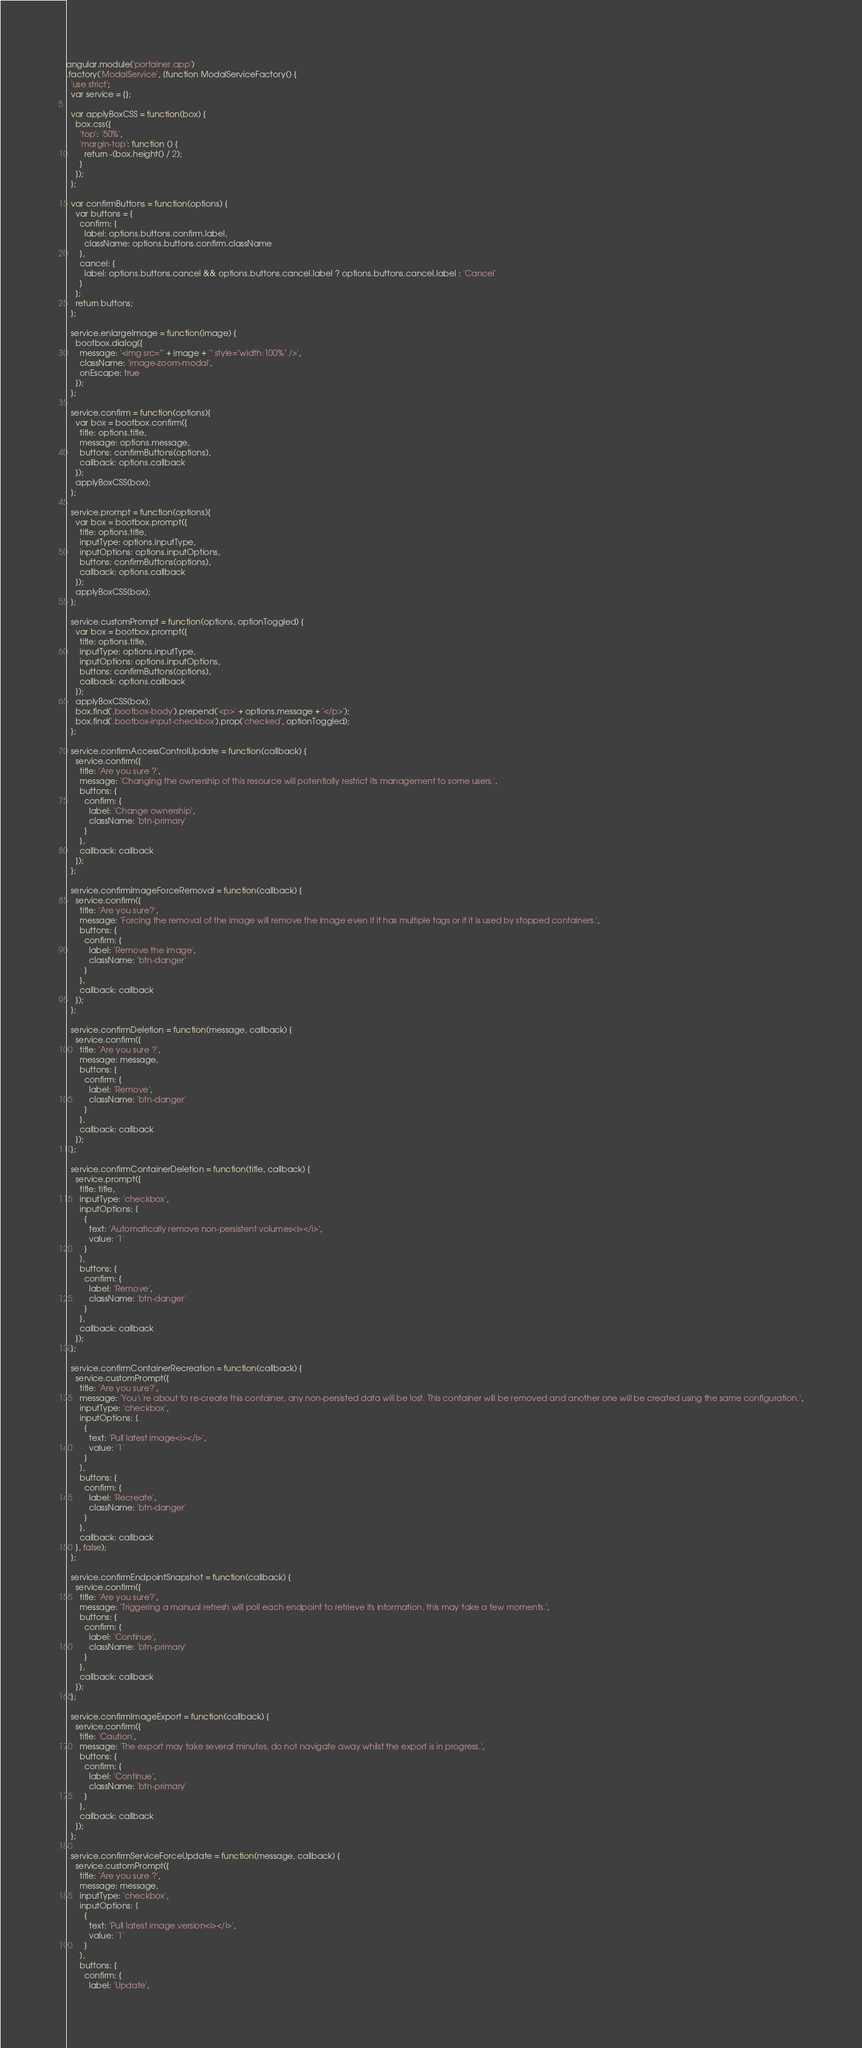Convert code to text. <code><loc_0><loc_0><loc_500><loc_500><_JavaScript_>angular.module('portainer.app')
.factory('ModalService', [function ModalServiceFactory() {
  'use strict';
  var service = {};

  var applyBoxCSS = function(box) {
    box.css({
      'top': '50%',
      'margin-top': function () {
        return -(box.height() / 2);
      }
    });
  };

  var confirmButtons = function(options) {
    var buttons = {
      confirm: {
        label: options.buttons.confirm.label,
        className: options.buttons.confirm.className
      },
      cancel: {
        label: options.buttons.cancel && options.buttons.cancel.label ? options.buttons.cancel.label : 'Cancel'
      }
    };
    return buttons;
  };

  service.enlargeImage = function(image) {
    bootbox.dialog({
      message: '<img src="' + image + '" style="width:100%" />',
      className: 'image-zoom-modal',
      onEscape: true
    });
  };

  service.confirm = function(options){
    var box = bootbox.confirm({
      title: options.title,
      message: options.message,
      buttons: confirmButtons(options),
      callback: options.callback
    });
    applyBoxCSS(box);
  };

  service.prompt = function(options){
    var box = bootbox.prompt({
      title: options.title,
      inputType: options.inputType,
      inputOptions: options.inputOptions,
      buttons: confirmButtons(options),
      callback: options.callback
    });
    applyBoxCSS(box);
  };

  service.customPrompt = function(options, optionToggled) {
    var box = bootbox.prompt({
      title: options.title,
      inputType: options.inputType,
      inputOptions: options.inputOptions,
      buttons: confirmButtons(options),
      callback: options.callback
    });
    applyBoxCSS(box);
    box.find('.bootbox-body').prepend('<p>' + options.message + '</p>');
    box.find('.bootbox-input-checkbox').prop('checked', optionToggled);
  };

  service.confirmAccessControlUpdate = function(callback) {
    service.confirm({
      title: 'Are you sure ?',
      message: 'Changing the ownership of this resource will potentially restrict its management to some users.',
      buttons: {
        confirm: {
          label: 'Change ownership',
          className: 'btn-primary'
        }
      },
      callback: callback
    });
  };

  service.confirmImageForceRemoval = function(callback) {
    service.confirm({
      title: 'Are you sure?',
      message: 'Forcing the removal of the image will remove the image even if it has multiple tags or if it is used by stopped containers.',
      buttons: {
        confirm: {
          label: 'Remove the image',
          className: 'btn-danger'
        }
      },
      callback: callback
    });
  };

  service.confirmDeletion = function(message, callback) {
    service.confirm({
      title: 'Are you sure ?',
      message: message,
      buttons: {
        confirm: {
          label: 'Remove',
          className: 'btn-danger'
        }
      },
      callback: callback
    });
  };

  service.confirmContainerDeletion = function(title, callback) {
    service.prompt({
      title: title,
      inputType: 'checkbox',
      inputOptions: [
        {
          text: 'Automatically remove non-persistent volumes<i></i>',
          value: '1'
        }
      ],
      buttons: {
        confirm: {
          label: 'Remove',
          className: 'btn-danger'
        }
      },
      callback: callback
    });
  };

  service.confirmContainerRecreation = function(callback) {
    service.customPrompt({
      title: 'Are you sure?',
      message: 'You\'re about to re-create this container, any non-persisted data will be lost. This container will be removed and another one will be created using the same configuration.',
      inputType: 'checkbox',
      inputOptions: [
        {
          text: 'Pull latest image<i></i>',
          value: '1'
        }
      ],
      buttons: {
        confirm: {
          label: 'Recreate',
          className: 'btn-danger'
        }
      },
      callback: callback
    }, false);
  };

  service.confirmEndpointSnapshot = function(callback) {
    service.confirm({
      title: 'Are you sure?',
      message: 'Triggering a manual refresh will poll each endpoint to retrieve its information, this may take a few moments.',
      buttons: {
        confirm: {
          label: 'Continue',
          className: 'btn-primary'
        }
      },
      callback: callback
    });
  };

  service.confirmImageExport = function(callback) {
    service.confirm({
      title: 'Caution',
      message: 'The export may take several minutes, do not navigate away whilst the export is in progress.',
      buttons: {
        confirm: {
          label: 'Continue',
          className: 'btn-primary'
        }
      },
      callback: callback
    });
  };

  service.confirmServiceForceUpdate = function(message, callback) {
    service.customPrompt({
      title: 'Are you sure ?',
      message: message,
      inputType: 'checkbox',
      inputOptions: [
        {
          text: 'Pull latest image version<i></i>',
          value: '1'
        }
      ],
      buttons: {
        confirm: {
          label: 'Update',</code> 